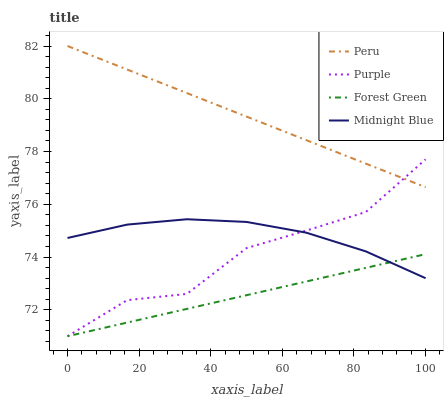Does Forest Green have the minimum area under the curve?
Answer yes or no. Yes. Does Peru have the maximum area under the curve?
Answer yes or no. Yes. Does Midnight Blue have the minimum area under the curve?
Answer yes or no. No. Does Midnight Blue have the maximum area under the curve?
Answer yes or no. No. Is Forest Green the smoothest?
Answer yes or no. Yes. Is Purple the roughest?
Answer yes or no. Yes. Is Midnight Blue the smoothest?
Answer yes or no. No. Is Midnight Blue the roughest?
Answer yes or no. No. Does Purple have the lowest value?
Answer yes or no. Yes. Does Midnight Blue have the lowest value?
Answer yes or no. No. Does Peru have the highest value?
Answer yes or no. Yes. Does Midnight Blue have the highest value?
Answer yes or no. No. Is Midnight Blue less than Peru?
Answer yes or no. Yes. Is Peru greater than Forest Green?
Answer yes or no. Yes. Does Purple intersect Midnight Blue?
Answer yes or no. Yes. Is Purple less than Midnight Blue?
Answer yes or no. No. Is Purple greater than Midnight Blue?
Answer yes or no. No. Does Midnight Blue intersect Peru?
Answer yes or no. No. 